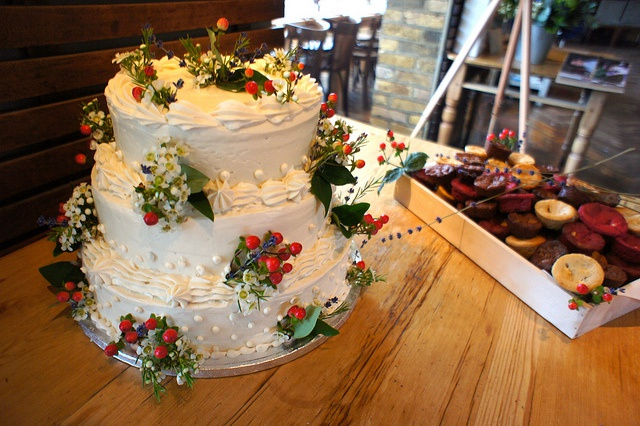Describe the objects in this image and their specific colors. I can see dining table in black, brown, maroon, and orange tones, cake in black, tan, and darkgray tones, book in black and gray tones, chair in black, gray, and darkgray tones, and chair in black and gray tones in this image. 